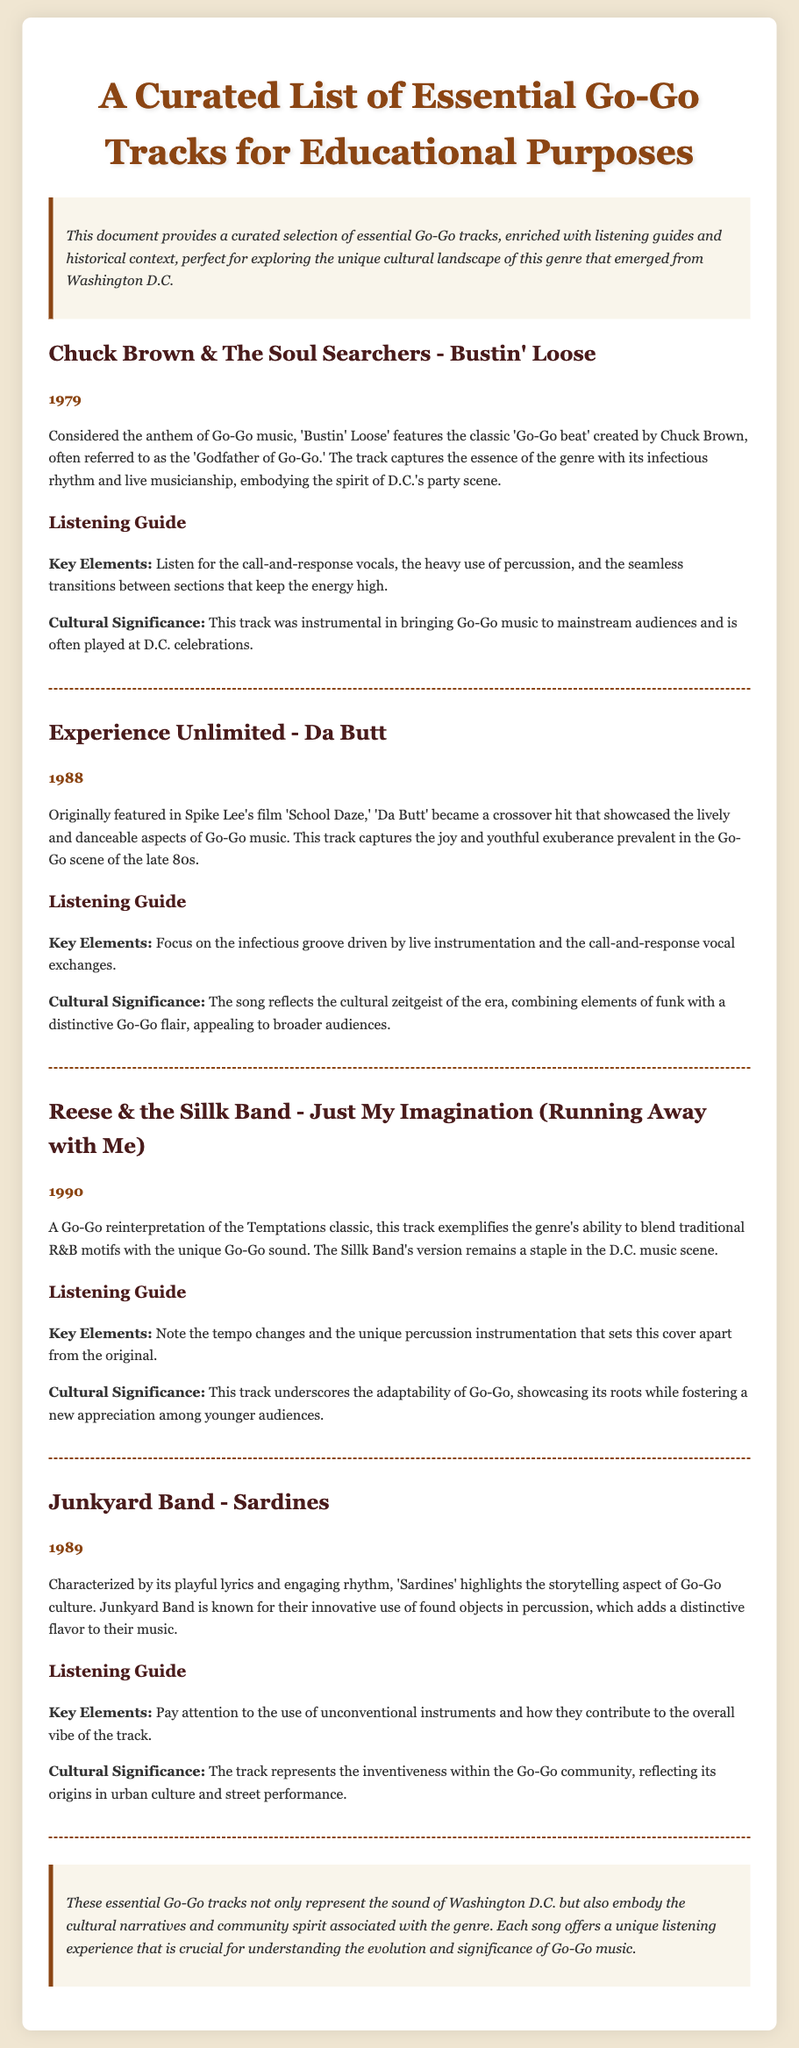What is the title of the document? The title is provided at the top of the document.
Answer: A Curated List of Essential Go-Go Tracks for Educational Purposes Who is considered the Godfather of Go-Go? This information is found in the section about 'Bustin' Loose.'
Answer: Chuck Brown In which year was 'Da Butt' released? The year of release is mentioned with the track details.
Answer: 1988 What track is characterized by playful lyrics and engaging rhythm? Described in the section about 'Sardines.'
Answer: Sardines What is a key element to listen for in 'Just My Imagination'? The listening guide section outlines this focus.
Answer: Tempo changes What cultural significance is attributed to 'Bustin' Loose'? The document describes its impact in the context provided.
Answer: Instrumental in bringing Go-Go music to mainstream audiences Which band is mentioned as having innovative use of found objects? This is discussed in the context of the 'Sardines' track.
Answer: Junkyard Band What genre did 'Da Butt' showcase? The document specifies the genre in the description.
Answer: Go-Go music 